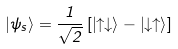Convert formula to latex. <formula><loc_0><loc_0><loc_500><loc_500>\left | \psi _ { s } \right \rangle = \frac { 1 } { \sqrt { 2 } } \left [ \left | \uparrow \downarrow \right \rangle - \left | \downarrow \uparrow \right \rangle \right ]</formula> 